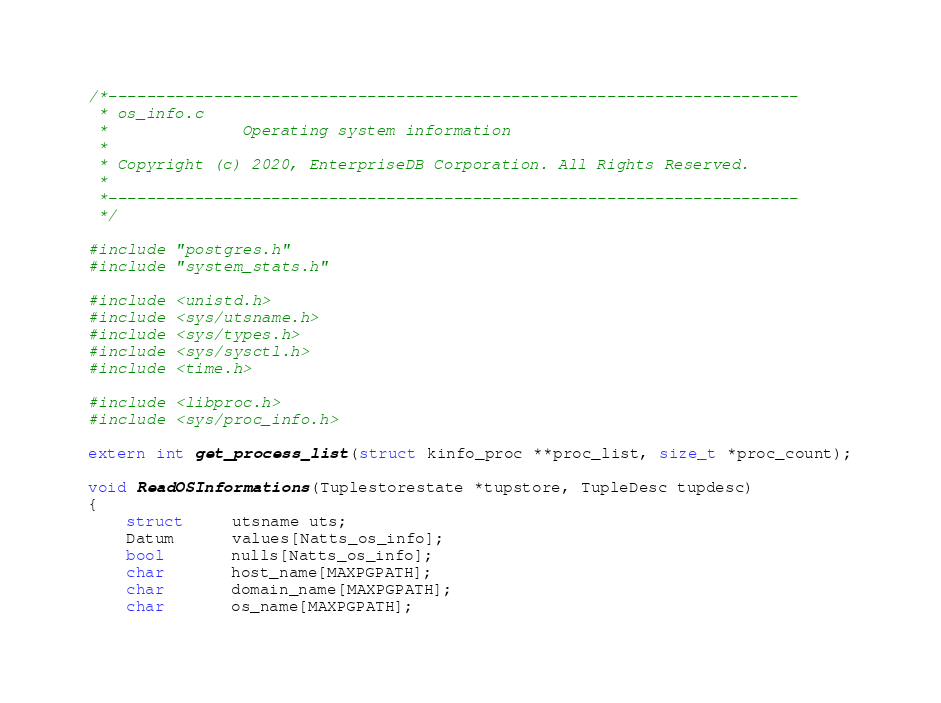<code> <loc_0><loc_0><loc_500><loc_500><_C_>/*------------------------------------------------------------------------
 * os_info.c
 *              Operating system information
 *
 * Copyright (c) 2020, EnterpriseDB Corporation. All Rights Reserved.
 *
 *------------------------------------------------------------------------
 */

#include "postgres.h"
#include "system_stats.h"

#include <unistd.h>
#include <sys/utsname.h>
#include <sys/types.h>
#include <sys/sysctl.h>
#include <time.h>

#include <libproc.h>
#include <sys/proc_info.h>

extern int get_process_list(struct kinfo_proc **proc_list, size_t *proc_count);

void ReadOSInformations(Tuplestorestate *tupstore, TupleDesc tupdesc)
{
	struct     utsname uts;
	Datum      values[Natts_os_info];
	bool       nulls[Natts_os_info];
	char       host_name[MAXPGPATH];
	char       domain_name[MAXPGPATH];
	char       os_name[MAXPGPATH];</code> 